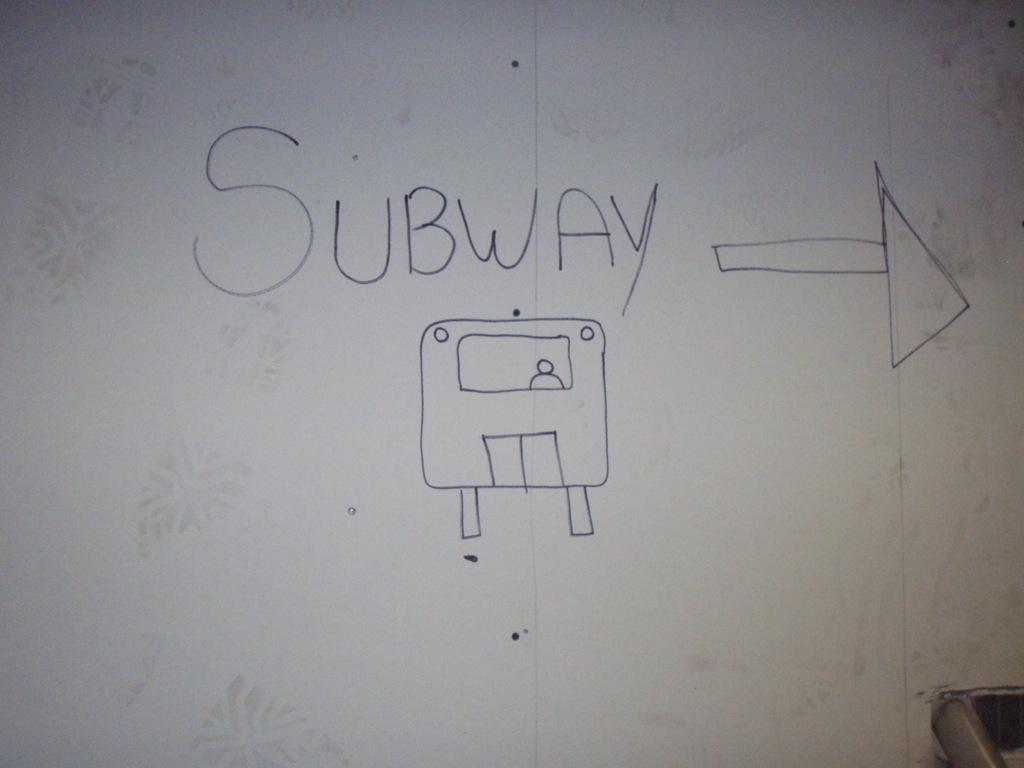What is present on the wall in the image? There is text and a symbol on the wall in the image. Can you describe the text on the wall? Unfortunately, the specific content of the text cannot be determined from the image alone. What type of symbol is on the wall? The image only provides a visual representation of the symbol, so its meaning or type cannot be determined without additional context. How many horses are visible in the image? There are no horses present in the image; it only features a wall with text and a symbol. What type of alarm is depicted on the wall? There is no alarm present in the image; it only features a wall with text and a symbol. 